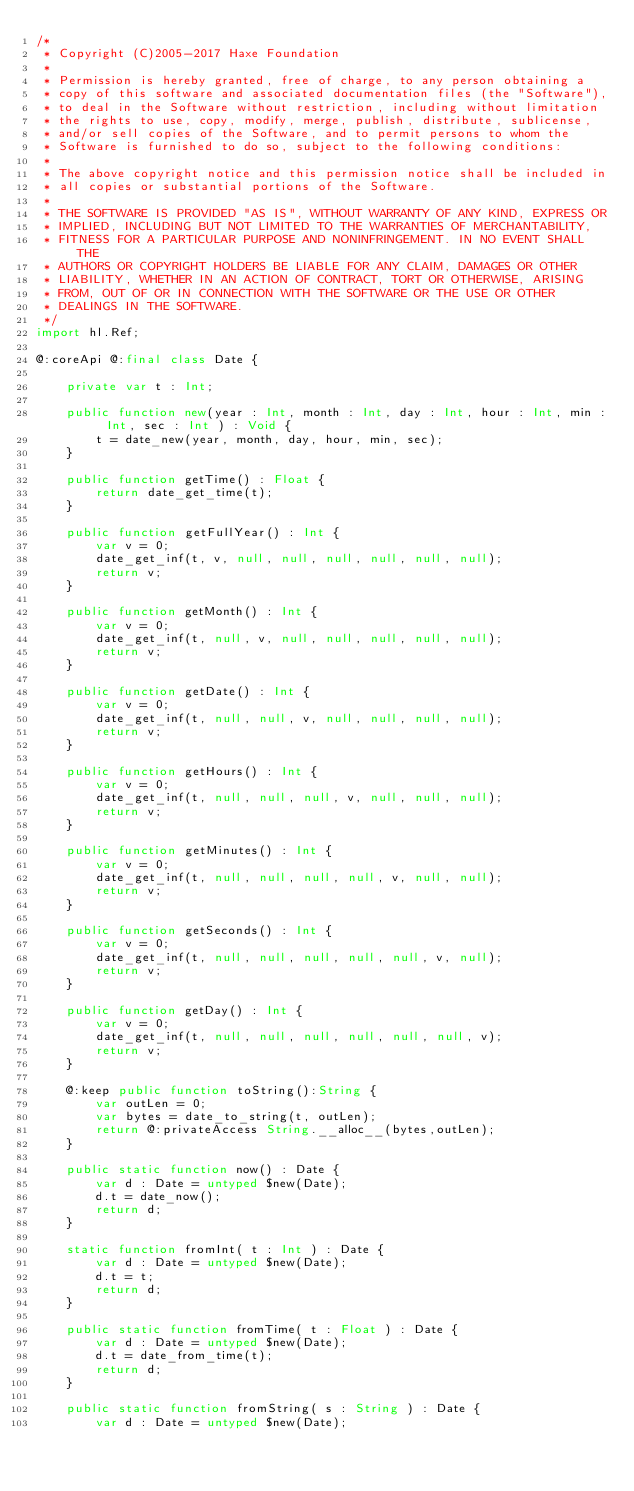Convert code to text. <code><loc_0><loc_0><loc_500><loc_500><_Haxe_>/*
 * Copyright (C)2005-2017 Haxe Foundation
 *
 * Permission is hereby granted, free of charge, to any person obtaining a
 * copy of this software and associated documentation files (the "Software"),
 * to deal in the Software without restriction, including without limitation
 * the rights to use, copy, modify, merge, publish, distribute, sublicense,
 * and/or sell copies of the Software, and to permit persons to whom the
 * Software is furnished to do so, subject to the following conditions:
 *
 * The above copyright notice and this permission notice shall be included in
 * all copies or substantial portions of the Software.
 *
 * THE SOFTWARE IS PROVIDED "AS IS", WITHOUT WARRANTY OF ANY KIND, EXPRESS OR
 * IMPLIED, INCLUDING BUT NOT LIMITED TO THE WARRANTIES OF MERCHANTABILITY,
 * FITNESS FOR A PARTICULAR PURPOSE AND NONINFRINGEMENT. IN NO EVENT SHALL THE
 * AUTHORS OR COPYRIGHT HOLDERS BE LIABLE FOR ANY CLAIM, DAMAGES OR OTHER
 * LIABILITY, WHETHER IN AN ACTION OF CONTRACT, TORT OR OTHERWISE, ARISING
 * FROM, OUT OF OR IN CONNECTION WITH THE SOFTWARE OR THE USE OR OTHER
 * DEALINGS IN THE SOFTWARE.
 */
import hl.Ref;

@:coreApi @:final class Date {

	private var t : Int;

	public function new(year : Int, month : Int, day : Int, hour : Int, min : Int, sec : Int ) : Void {
		t = date_new(year, month, day, hour, min, sec);
	}

	public function getTime() : Float {
		return date_get_time(t);
	}

	public function getFullYear() : Int {
		var v = 0;
		date_get_inf(t, v, null, null, null, null, null, null);
		return v;
	}

	public function getMonth() : Int {
		var v = 0;
		date_get_inf(t, null, v, null, null, null, null, null);
		return v;
	}

	public function getDate() : Int {
		var v = 0;
		date_get_inf(t, null, null, v, null, null, null, null);
		return v;
	}

	public function getHours() : Int {
		var v = 0;
		date_get_inf(t, null, null, null, v, null, null, null);
		return v;
	}

	public function getMinutes() : Int {
		var v = 0;
		date_get_inf(t, null, null, null, null, v, null, null);
		return v;
	}

	public function getSeconds() : Int {
		var v = 0;
		date_get_inf(t, null, null, null, null, null, v, null);
		return v;
	}

	public function getDay() : Int {
		var v = 0;
		date_get_inf(t, null, null, null, null, null, null, v);
		return v;
	}

	@:keep public function toString():String {
		var outLen = 0;
		var bytes = date_to_string(t, outLen);
		return @:privateAccess String.__alloc__(bytes,outLen);
	}

	public static function now() : Date {
		var d : Date = untyped $new(Date);
		d.t = date_now();
		return d;
	}

	static function fromInt( t : Int ) : Date {
		var d : Date = untyped $new(Date);
		d.t = t;
		return d;
	}

	public static function fromTime( t : Float ) : Date {
		var d : Date = untyped $new(Date);
		d.t = date_from_time(t);
		return d;
	}

	public static function fromString( s : String ) : Date {
		var d : Date = untyped $new(Date);</code> 